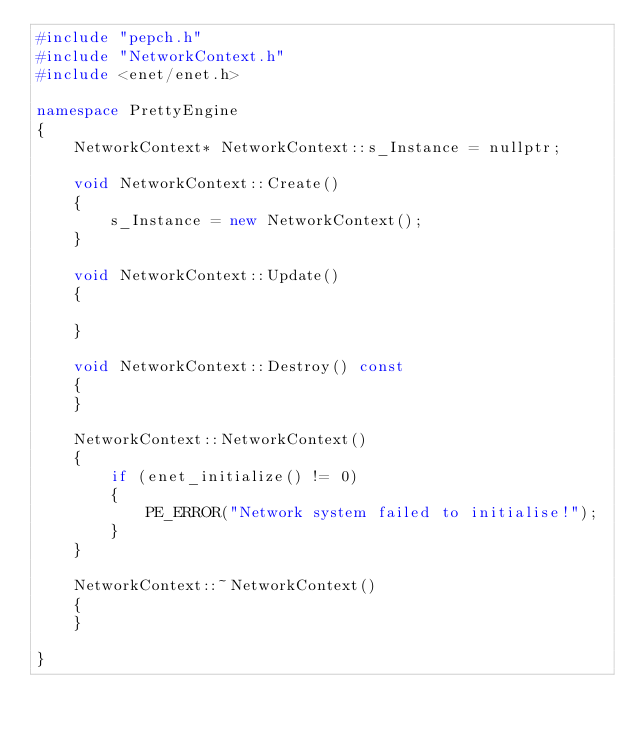<code> <loc_0><loc_0><loc_500><loc_500><_C++_>#include "pepch.h"
#include "NetworkContext.h"
#include <enet/enet.h>

namespace PrettyEngine 
{
	NetworkContext* NetworkContext::s_Instance = nullptr;

	void NetworkContext::Create()
	{
		s_Instance = new NetworkContext();
	}

	void NetworkContext::Update()
	{

	}

	void NetworkContext::Destroy() const
	{
	}

	NetworkContext::NetworkContext()
	{
		if (enet_initialize() != 0)
		{
			PE_ERROR("Network system failed to initialise!");
		}
	}

	NetworkContext::~NetworkContext()
	{
	}

}</code> 